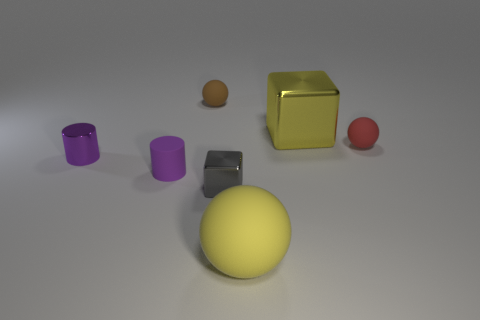Subtract all tiny balls. How many balls are left? 1 Add 1 tiny blocks. How many objects exist? 8 Subtract all yellow balls. How many balls are left? 2 Subtract all big brown matte blocks. Subtract all yellow blocks. How many objects are left? 6 Add 2 small blocks. How many small blocks are left? 3 Add 7 small red rubber spheres. How many small red rubber spheres exist? 8 Subtract 0 cyan blocks. How many objects are left? 7 Subtract all blocks. How many objects are left? 5 Subtract all brown blocks. Subtract all yellow spheres. How many blocks are left? 2 